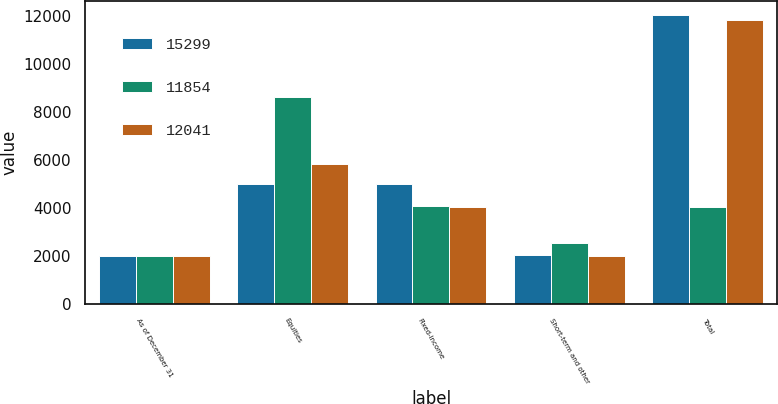Convert chart. <chart><loc_0><loc_0><loc_500><loc_500><stacked_bar_chart><ecel><fcel>As of December 31<fcel>Equities<fcel>Fixed-income<fcel>Short-term and other<fcel>Total<nl><fcel>15299<fcel>2008<fcel>5003<fcel>5014<fcel>2024<fcel>12041<nl><fcel>11854<fcel>2007<fcel>8653<fcel>4087<fcel>2559<fcel>4061<nl><fcel>12041<fcel>2006<fcel>5821<fcel>4035<fcel>1998<fcel>11854<nl></chart> 